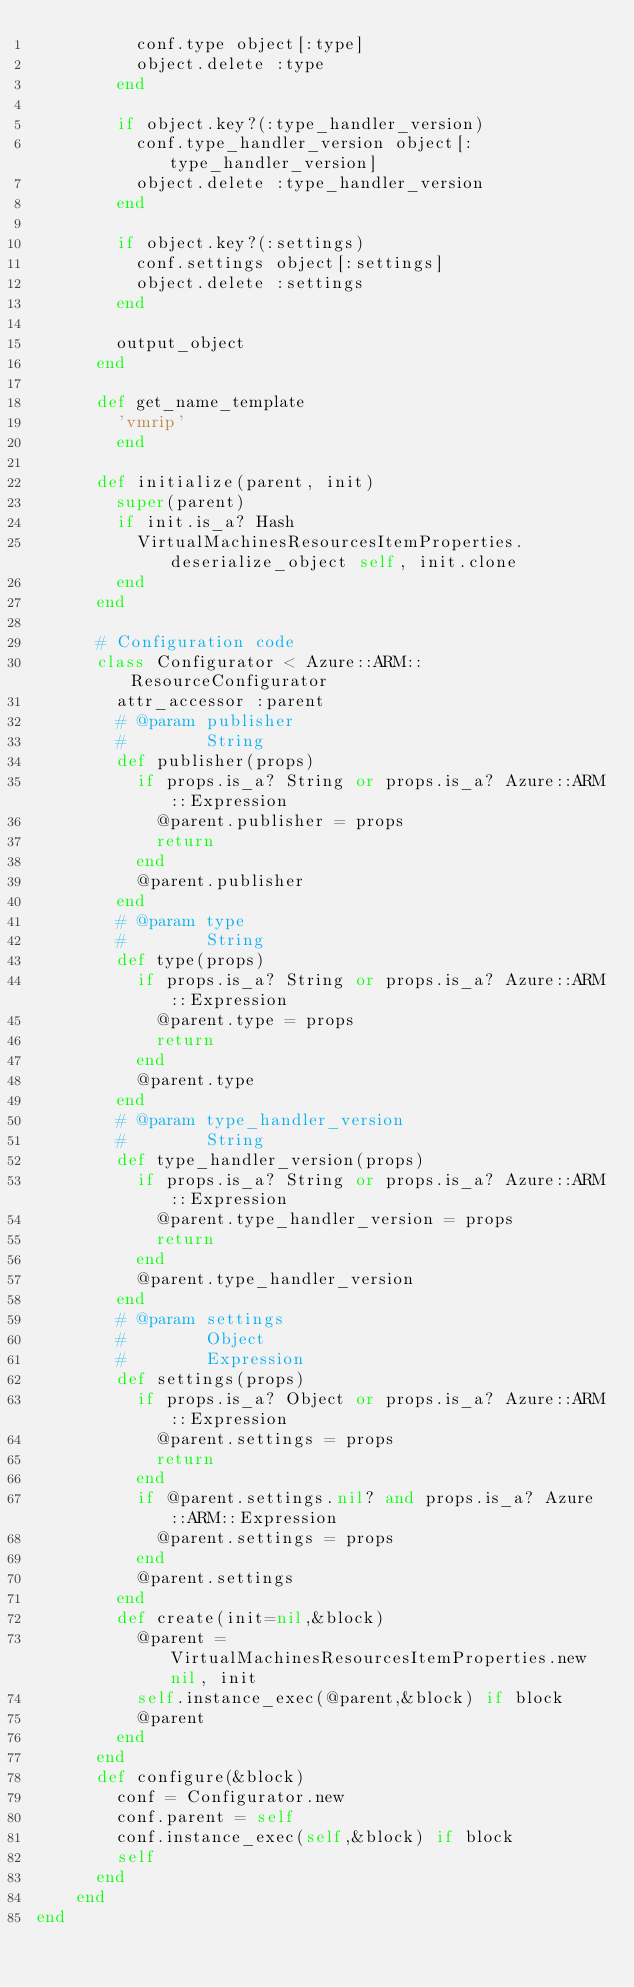<code> <loc_0><loc_0><loc_500><loc_500><_Ruby_>          conf.type object[:type]
          object.delete :type
        end

        if object.key?(:type_handler_version)
          conf.type_handler_version object[:type_handler_version]
          object.delete :type_handler_version
        end

        if object.key?(:settings)
          conf.settings object[:settings]
          object.delete :settings
        end

        output_object
      end

      def get_name_template
        'vmrip'
        end

      def initialize(parent, init)
        super(parent)
        if init.is_a? Hash
          VirtualMachinesResourcesItemProperties.deserialize_object self, init.clone
        end
      end

      # Configuration code
      class Configurator < Azure::ARM::ResourceConfigurator
        attr_accessor :parent
        # @param publisher
        #        String
        def publisher(props)
          if props.is_a? String or props.is_a? Azure::ARM::Expression
            @parent.publisher = props
            return
          end
          @parent.publisher
        end
        # @param type
        #        String
        def type(props)
          if props.is_a? String or props.is_a? Azure::ARM::Expression
            @parent.type = props
            return
          end
          @parent.type
        end
        # @param type_handler_version
        #        String
        def type_handler_version(props)
          if props.is_a? String or props.is_a? Azure::ARM::Expression
            @parent.type_handler_version = props
            return
          end
          @parent.type_handler_version
        end
        # @param settings
        #        Object
        #        Expression
        def settings(props)
          if props.is_a? Object or props.is_a? Azure::ARM::Expression
            @parent.settings = props
            return
          end
          if @parent.settings.nil? and props.is_a? Azure::ARM::Expression
            @parent.settings = props
          end
          @parent.settings
        end
        def create(init=nil,&block)
          @parent = VirtualMachinesResourcesItemProperties.new nil, init
          self.instance_exec(@parent,&block) if block
          @parent
        end
      end
      def configure(&block)
        conf = Configurator.new
        conf.parent = self
        conf.instance_exec(self,&block) if block
        self
      end
    end
end
</code> 